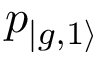Convert formula to latex. <formula><loc_0><loc_0><loc_500><loc_500>p _ { | { g , 1 \rangle } }</formula> 